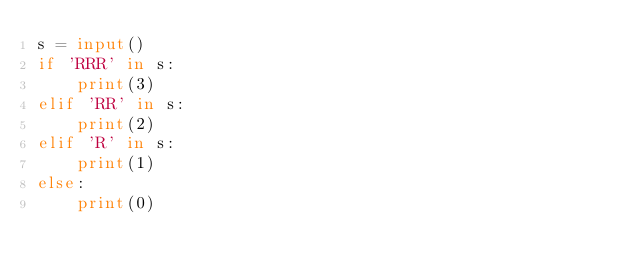Convert code to text. <code><loc_0><loc_0><loc_500><loc_500><_Python_>s = input()
if 'RRR' in s:
    print(3)
elif 'RR' in s:
    print(2)
elif 'R' in s:
    print(1)
else:
    print(0)</code> 